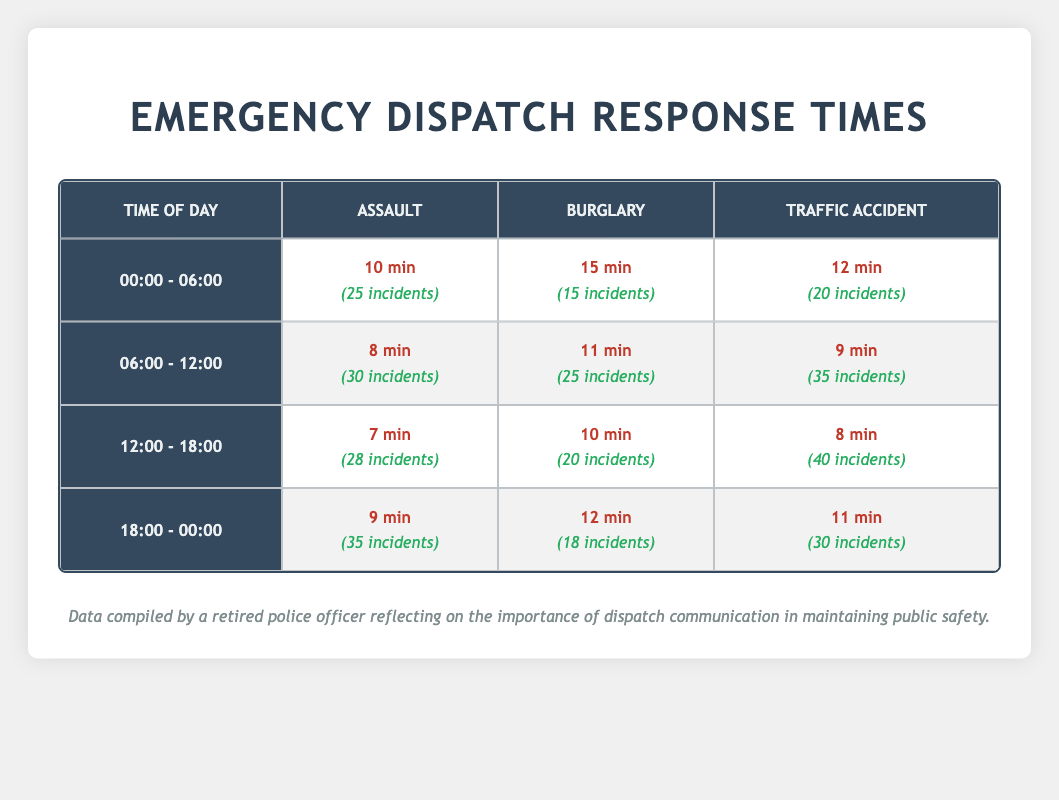What is the average response time for assault incidents between 12:00 and 18:00? The average response time for assault incidents during this time is 7 minutes, as provided in the table under the "Assault" column for the "12:00 - 18:00" row.
Answer: 7 minutes Which type of incident had the fastest average response time in the morning (06:00 - 12:00)? The fastest average response time in the morning was for assault incidents, which averaged 8 minutes, as shown in the "Assault" row of the "06:00 - 12:00" time slot.
Answer: Assault Is the average response time for burglary incidents higher during nighttime (00:00 - 06:00) than during evening (18:00 - 00:00)? Yes, the average response time for burglary incidents at night is 15 minutes, while in the evening it is 12 minutes, confirming that nighttime has a higher response time.
Answer: Yes What is the total number of traffic accident incidents reported between 00:00 and 12:00? The total number of traffic accident incidents between 00:00 and 12:00 can be calculated by adding the incidents from both time slots: 20 (from 00:00 - 06:00) + 35 (from 06:00 - 12:00) = 55 incidents total.
Answer: 55 incidents In which time period were the average response times for burglary incidents the lowest? The average response times for burglary incidents were lowest during the time period of 12:00 - 18:00 with an average of 10 minutes, compared to the other time periods listed.
Answer: 12:00 - 18:00 Are response times for traffic accidents generally lower compared to assault incidents across all time periods? No, this statement is false as there are time periods where traffic accident response times are higher than for assault incidents, such as during 18:00 - 00:00 where traffic accidents averaged 11 minutes while assaults averaged 9 minutes.
Answer: No What is the average response time for all incident types during the time period of 00:00 - 06:00? To find the average response time for all types of incidents during this period, sum the response times: (10 + 15 + 12) = 37 minutes, then divide by the number of types (3): 37/3 = 12.33 minutes (rounded can be expressed as approximately 12 minutes).
Answer: Approximately 12 minutes In terms of response times, how does the afternoon period (12:00 - 18:00) compare to the evening period (18:00 - 00:00) for traffic accidents? Comparing the two, the afternoon period has a quicker average response time of 8 minutes for traffic accidents versus 11 minutes in the evening, indicating that the afternoon is faster.
Answer: Afternoon is quicker 